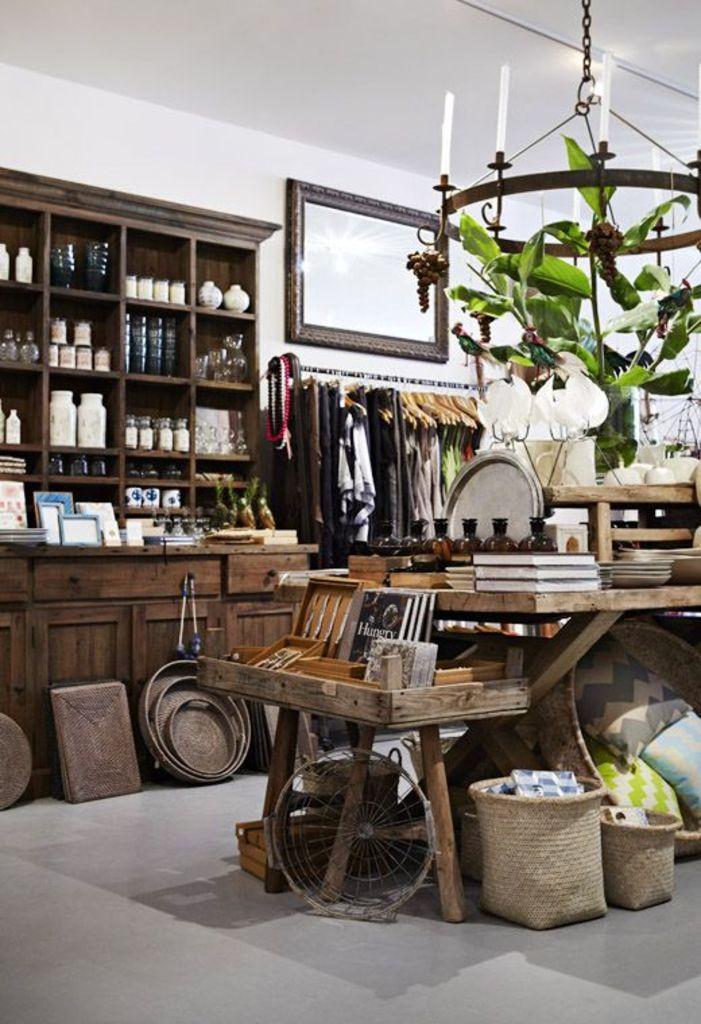Describe this image in one or two sentences. In the image, there is a big cupboard and there are some kitchenware kept in that, below that there are some other items made with wood to its right side there is a table and on the table there is some books,plates and bottles. To the left side there is collection of clothes, above that there is a big mirror,there is a chain to the roof and plants are hanged to that chain. 